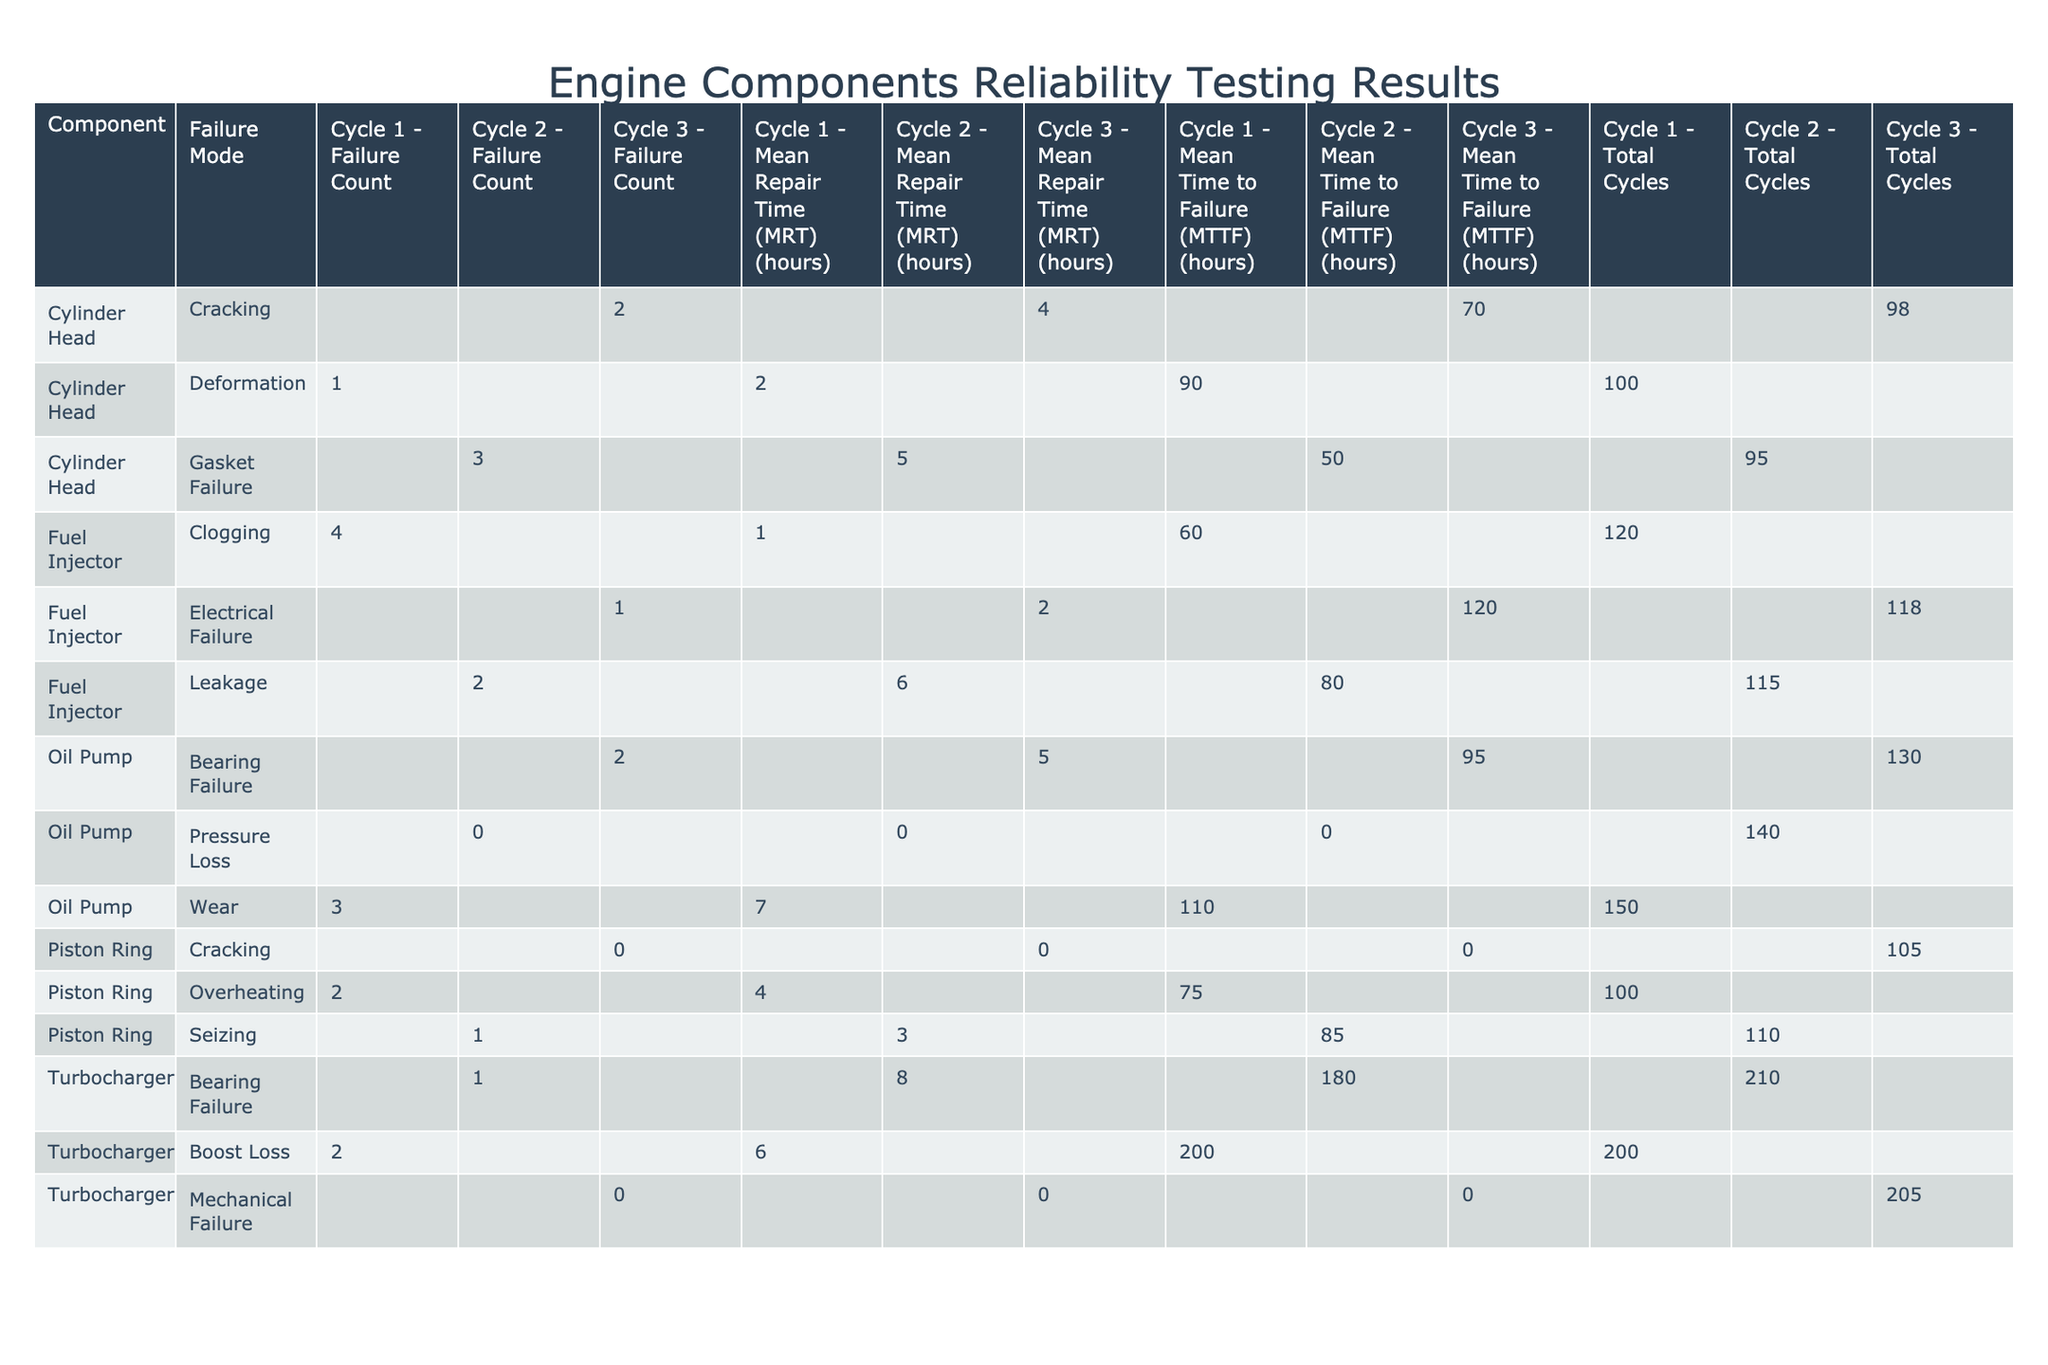What is the failure count for the Fuel Injector in Cycle 2? The table shows the Fuel Injector and its corresponding failure count for Cycle 2, which is listed as 2.
Answer: 2 What is the Mean Time to Failure (MTTF) for the Oil Pump in Cycle 1? The table indicates that the MTTF for the Oil Pump in Cycle 1 is 110 hours.
Answer: 110 hours Which component had the highest failure count in Cycle 1? By examining Cycle 1, the Fuel Injector has the highest failure count listed at 4.
Answer: Fuel Injector How many total cycles were recorded for the Cylinder Head? Summing the Total Cycles for the Cylinder Head across all test cycles (100 + 95 + 98), we get 293.
Answer: 293 Did any component experience a failure in Cycle 3? The table indicates that both the Piston Ring and Turbocharger had no failures in Cycle 3.
Answer: Yes, both had no failures Calculate the average Mean Repair Time (MRT) for the Piston Ring across all cycles. The MRT values for the Piston Ring are 4, 3, and 0 hours. Summing these gives 7, and dividing by 3 cycles yields an average of approximately 2.33 hours.
Answer: 2.33 hours Is the mean time to failure (MTTF) for the Cylinder Head in Cycle 2 lower than that of Cycle 1? The MTTF for Cylinder Head in Cycle 1 is 90 hours, while in Cycle 2, it is 50 hours. Therefore, it is lower in Cycle 2.
Answer: Yes What is the total failure count for all cycles of the Turbocharger? The failure counts from the table for Turbocharger are 2 (Cycle 1), 1 (Cycle 2), and 0 (Cycle 3). Totaling these gives a count of 3.
Answer: 3 Which failure mode for the Oil Pump in Cycle 2 had no failures? The relevant entry for Oil Pump in Cycle 2 lists "Pressure Loss" with a failure count of 0, indicating no failures occurred.
Answer: Pressure Loss How does the mean time to failure (MTTF) for the Fuel Injector in Cycle 1 compare to that in Cycle 3? The MTTF for Fuel Injector in Cycle 1 is 60 hours, while in Cycle 3 it is 120 hours. The average for Cycle 3 is higher than Cycle 1.
Answer: Cycle 3 has a higher MTTF 